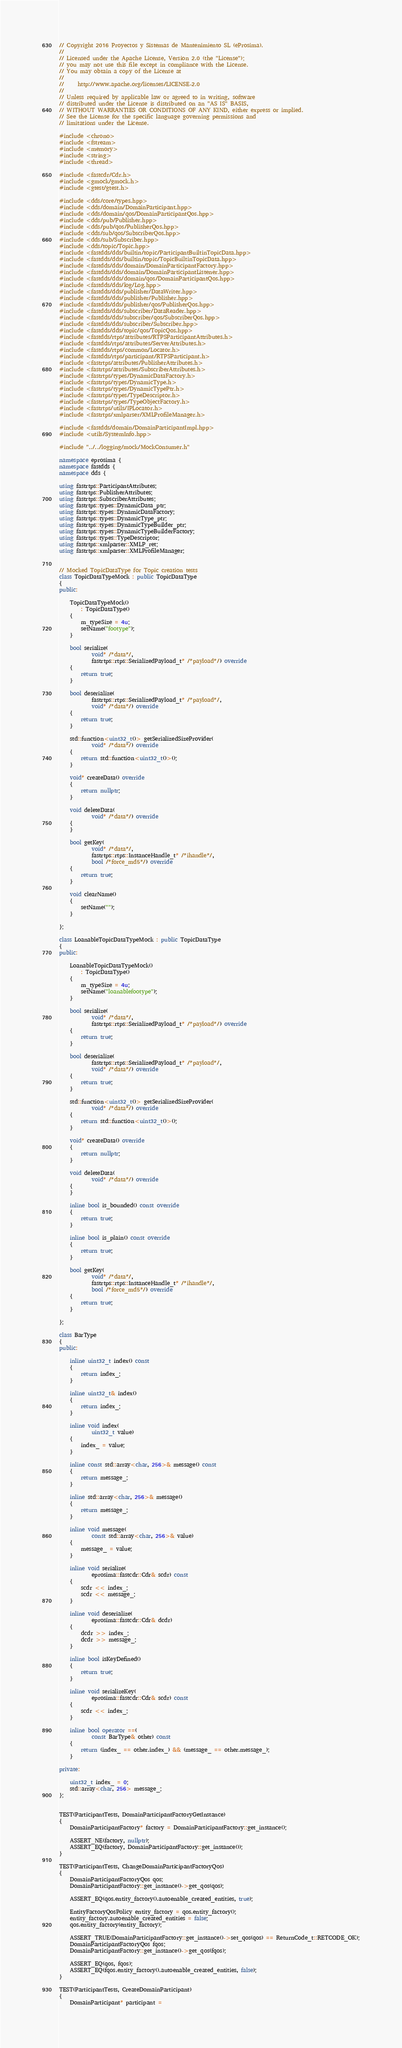Convert code to text. <code><loc_0><loc_0><loc_500><loc_500><_C++_>// Copyright 2016 Proyectos y Sistemas de Mantenimiento SL (eProsima).
//
// Licensed under the Apache License, Version 2.0 (the "License");
// you may not use this file except in compliance with the License.
// You may obtain a copy of the License at
//
//     http://www.apache.org/licenses/LICENSE-2.0
//
// Unless required by applicable law or agreed to in writing, software
// distributed under the License is distributed on an "AS IS" BASIS,
// WITHOUT WARRANTIES OR CONDITIONS OF ANY KIND, either express or implied.
// See the License for the specific language governing permissions and
// limitations under the License.

#include <chrono>
#include <fstream>
#include <memory>
#include <string>
#include <thread>

#include <fastcdr/Cdr.h>
#include <gmock/gmock.h>
#include <gtest/gtest.h>

#include <dds/core/types.hpp>
#include <dds/domain/DomainParticipant.hpp>
#include <dds/domain/qos/DomainParticipantQos.hpp>
#include <dds/pub/Publisher.hpp>
#include <dds/pub/qos/PublisherQos.hpp>
#include <dds/sub/qos/SubscriberQos.hpp>
#include <dds/sub/Subscriber.hpp>
#include <dds/topic/Topic.hpp>
#include <fastdds/dds/builtin/topic/ParticipantBuiltinTopicData.hpp>
#include <fastdds/dds/builtin/topic/TopicBuiltinTopicData.hpp>
#include <fastdds/dds/domain/DomainParticipantFactory.hpp>
#include <fastdds/dds/domain/DomainParticipantListener.hpp>
#include <fastdds/dds/domain/qos/DomainParticipantQos.hpp>
#include <fastdds/dds/log/Log.hpp>
#include <fastdds/dds/publisher/DataWriter.hpp>
#include <fastdds/dds/publisher/Publisher.hpp>
#include <fastdds/dds/publisher/qos/PublisherQos.hpp>
#include <fastdds/dds/subscriber/DataReader.hpp>
#include <fastdds/dds/subscriber/qos/SubscriberQos.hpp>
#include <fastdds/dds/subscriber/Subscriber.hpp>
#include <fastdds/dds/topic/qos/TopicQos.hpp>
#include <fastdds/rtps/attributes/RTPSParticipantAttributes.h>
#include <fastdds/rtps/attributes/ServerAttributes.h>
#include <fastdds/rtps/common/Locator.h>
#include <fastdds/rtps/participant/RTPSParticipant.h>
#include <fastrtps/attributes/PublisherAttributes.h>
#include <fastrtps/attributes/SubscriberAttributes.h>
#include <fastrtps/types/DynamicDataFactory.h>
#include <fastrtps/types/DynamicType.h>
#include <fastrtps/types/DynamicTypePtr.h>
#include <fastrtps/types/TypeDescriptor.h>
#include <fastrtps/types/TypeObjectFactory.h>
#include <fastrtps/utils/IPLocator.h>
#include <fastrtps/xmlparser/XMLProfileManager.h>

#include <fastdds/domain/DomainParticipantImpl.hpp>
#include <utils/SystemInfo.hpp>

#include "../../logging/mock/MockConsumer.h"

namespace eprosima {
namespace fastdds {
namespace dds {

using fastrtps::ParticipantAttributes;
using fastrtps::PublisherAttributes;
using fastrtps::SubscriberAttributes;
using fastrtps::types::DynamicData_ptr;
using fastrtps::types::DynamicDataFactory;
using fastrtps::types::DynamicType_ptr;
using fastrtps::types::DynamicTypeBuilder_ptr;
using fastrtps::types::DynamicTypeBuilderFactory;
using fastrtps::types::TypeDescriptor;
using fastrtps::xmlparser::XMLP_ret;
using fastrtps::xmlparser::XMLProfileManager;


// Mocked TopicDataType for Topic creation tests
class TopicDataTypeMock : public TopicDataType
{
public:

    TopicDataTypeMock()
        : TopicDataType()
    {
        m_typeSize = 4u;
        setName("footype");
    }

    bool serialize(
            void* /*data*/,
            fastrtps::rtps::SerializedPayload_t* /*payload*/) override
    {
        return true;
    }

    bool deserialize(
            fastrtps::rtps::SerializedPayload_t* /*payload*/,
            void* /*data*/) override
    {
        return true;
    }

    std::function<uint32_t()> getSerializedSizeProvider(
            void* /*data*/) override
    {
        return std::function<uint32_t()>();
    }

    void* createData() override
    {
        return nullptr;
    }

    void deleteData(
            void* /*data*/) override
    {
    }

    bool getKey(
            void* /*data*/,
            fastrtps::rtps::InstanceHandle_t* /*ihandle*/,
            bool /*force_md5*/) override
    {
        return true;
    }

    void clearName()
    {
        setName("");
    }

};

class LoanableTopicDataTypeMock : public TopicDataType
{
public:

    LoanableTopicDataTypeMock()
        : TopicDataType()
    {
        m_typeSize = 4u;
        setName("loanablefootype");
    }

    bool serialize(
            void* /*data*/,
            fastrtps::rtps::SerializedPayload_t* /*payload*/) override
    {
        return true;
    }

    bool deserialize(
            fastrtps::rtps::SerializedPayload_t* /*payload*/,
            void* /*data*/) override
    {
        return true;
    }

    std::function<uint32_t()> getSerializedSizeProvider(
            void* /*data*/) override
    {
        return std::function<uint32_t()>();
    }

    void* createData() override
    {
        return nullptr;
    }

    void deleteData(
            void* /*data*/) override
    {
    }

    inline bool is_bounded() const override
    {
        return true;
    }

    inline bool is_plain() const override
    {
        return true;
    }

    bool getKey(
            void* /*data*/,
            fastrtps::rtps::InstanceHandle_t* /*ihandle*/,
            bool /*force_md5*/) override
    {
        return true;
    }

};

class BarType
{
public:

    inline uint32_t index() const
    {
        return index_;
    }

    inline uint32_t& index()
    {
        return index_;
    }

    inline void index(
            uint32_t value)
    {
        index_ = value;
    }

    inline const std::array<char, 256>& message() const
    {
        return message_;
    }

    inline std::array<char, 256>& message()
    {
        return message_;
    }

    inline void message(
            const std::array<char, 256>& value)
    {
        message_ = value;
    }

    inline void serialize(
            eprosima::fastcdr::Cdr& scdr) const
    {
        scdr << index_;
        scdr << message_;
    }

    inline void deserialize(
            eprosima::fastcdr::Cdr& dcdr)
    {
        dcdr >> index_;
        dcdr >> message_;
    }

    inline bool isKeyDefined()
    {
        return true;
    }

    inline void serializeKey(
            eprosima::fastcdr::Cdr& scdr) const
    {
        scdr << index_;
    }

    inline bool operator ==(
            const BarType& other) const
    {
        return (index_ == other.index_) && (message_ == other.message_);
    }

private:

    uint32_t index_ = 0;
    std::array<char, 256> message_;
};


TEST(ParticipantTests, DomainParticipantFactoryGetInstance)
{
    DomainParticipantFactory* factory = DomainParticipantFactory::get_instance();

    ASSERT_NE(factory, nullptr);
    ASSERT_EQ(factory, DomainParticipantFactory::get_instance());
}

TEST(ParticipantTests, ChangeDomainParticipantFactoryQos)
{
    DomainParticipantFactoryQos qos;
    DomainParticipantFactory::get_instance()->get_qos(qos);

    ASSERT_EQ(qos.entity_factory().autoenable_created_entities, true);

    EntityFactoryQosPolicy entity_factory = qos.entity_factory();
    entity_factory.autoenable_created_entities = false;
    qos.entity_factory(entity_factory);

    ASSERT_TRUE(DomainParticipantFactory::get_instance()->set_qos(qos) == ReturnCode_t::RETCODE_OK);
    DomainParticipantFactoryQos fqos;
    DomainParticipantFactory::get_instance()->get_qos(fqos);

    ASSERT_EQ(qos, fqos);
    ASSERT_EQ(fqos.entity_factory().autoenable_created_entities, false);
}

TEST(ParticipantTests, CreateDomainParticipant)
{
    DomainParticipant* participant =</code> 